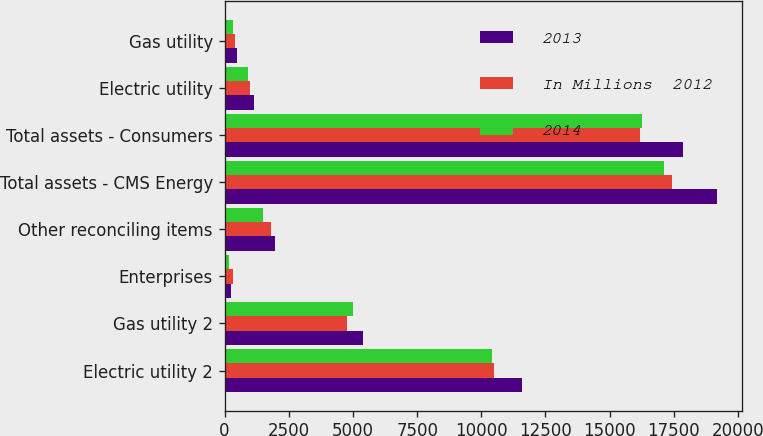Convert chart to OTSL. <chart><loc_0><loc_0><loc_500><loc_500><stacked_bar_chart><ecel><fcel>Electric utility 2<fcel>Gas utility 2<fcel>Enterprises<fcel>Other reconciling items<fcel>Total assets - CMS Energy<fcel>Total assets - Consumers<fcel>Electric utility<fcel>Gas utility<nl><fcel>2013<fcel>11582<fcel>5391<fcel>231<fcel>1981<fcel>19185<fcel>17847<fcel>1139<fcel>473<nl><fcel>In Millions  2012<fcel>10487<fcel>4784<fcel>332<fcel>1813<fcel>17416<fcel>16179<fcel>996<fcel>407<nl><fcel>2014<fcel>10423<fcel>5016<fcel>181<fcel>1511<fcel>17131<fcel>16275<fcel>921<fcel>340<nl></chart> 